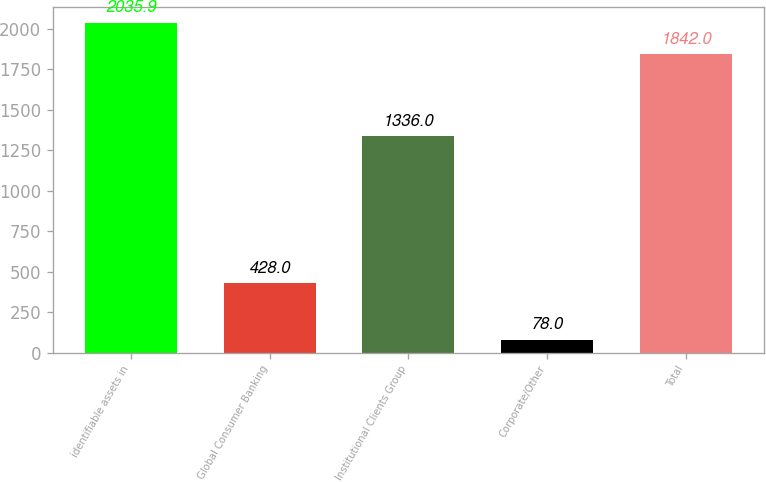Convert chart to OTSL. <chart><loc_0><loc_0><loc_500><loc_500><bar_chart><fcel>identifiable assets in<fcel>Global Consumer Banking<fcel>Institutional Clients Group<fcel>Corporate/Other<fcel>Total<nl><fcel>2035.9<fcel>428<fcel>1336<fcel>78<fcel>1842<nl></chart> 